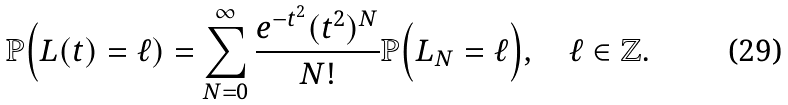<formula> <loc_0><loc_0><loc_500><loc_500>\mathbb { P } \Big ( L ( t ) = \ell ) = \sum _ { N = 0 } ^ { \infty } \frac { e ^ { - t ^ { 2 } } ( t ^ { 2 } ) ^ { N } } { N ! } \mathbb { P } \Big ( L _ { N } = \ell \Big ) , \quad \ell \in \mathbb { Z } .</formula> 